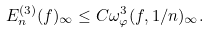<formula> <loc_0><loc_0><loc_500><loc_500>E ^ { ( 3 ) } _ { n } ( f ) _ { \infty } \leq C \omega ^ { 3 } _ { \varphi } ( f , 1 / n ) _ { \infty } .</formula> 